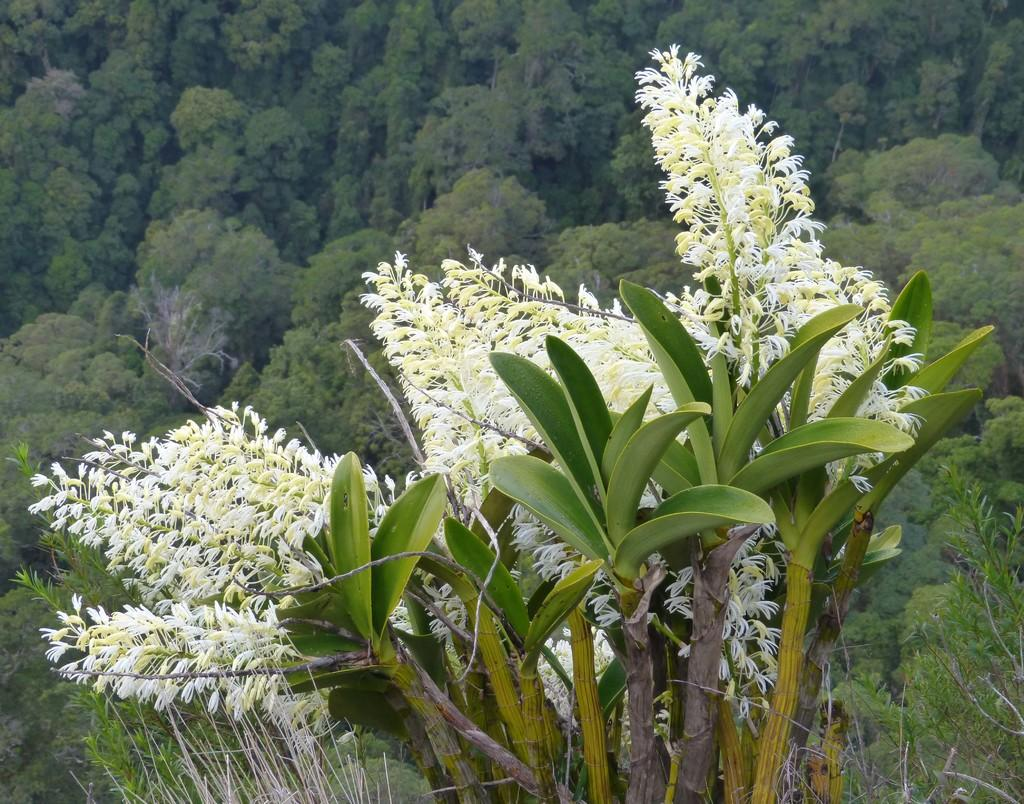What type of flora is present in the image? There are flowers in the image. What color are the flowers? The flowers are white in color. What can be seen in the background of the image? There are trees in the background of the image. What color are the trees? The trees are green in color. Are there any clouds visible in the image? There is no mention of clouds in the provided facts, so we cannot determine if any are visible in the image. Is there a deer present in the image? There is no mention of a deer in the provided facts, so we cannot determine if one is present in the image. 